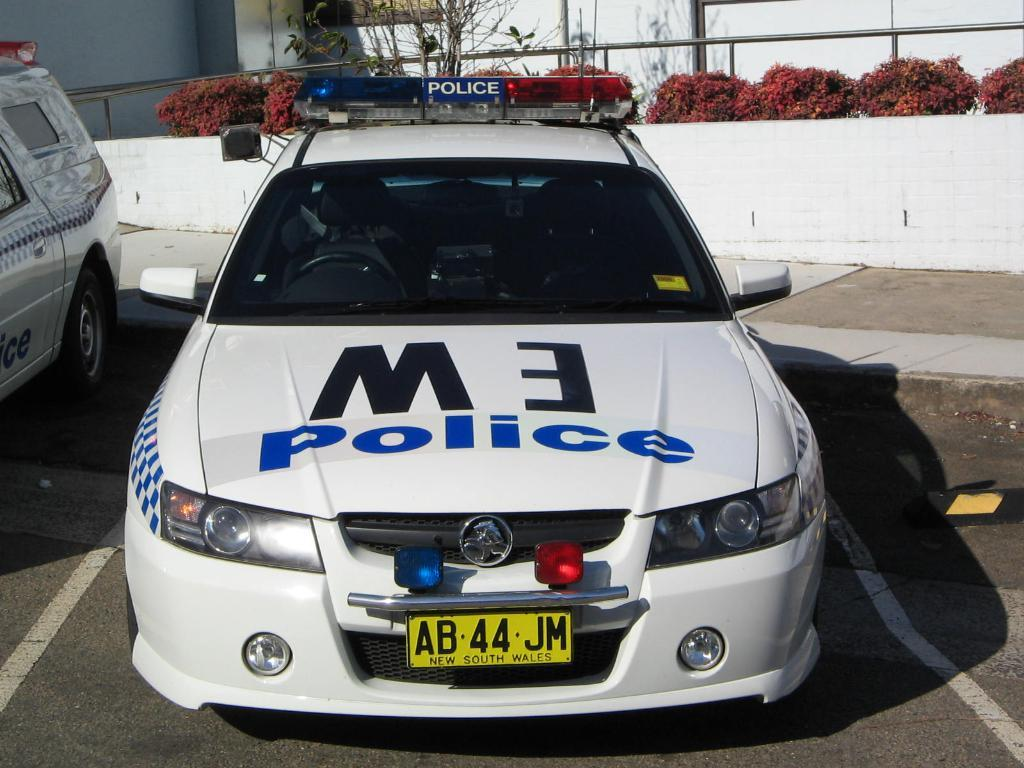What vehicles are present on the road in the image? There are 2 police cars on the road in the image. What can be seen in the background of the image? There are plants and a wall visible in the background. What type of spark can be seen coming from the police cars in the image? There is no spark visible coming from the police cars in the image. 